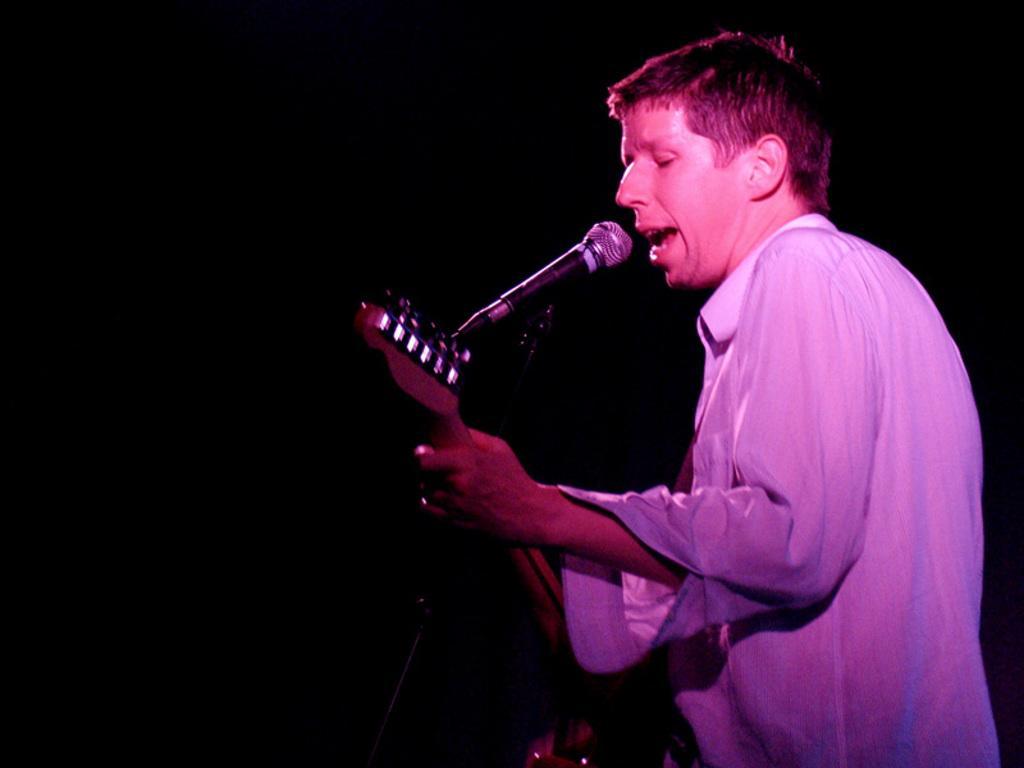Can you describe this image briefly? This picture is clicked in a musical concert. The man in white shirt is holding guitar in his hands and playing it. He is even singing song on microphone. 